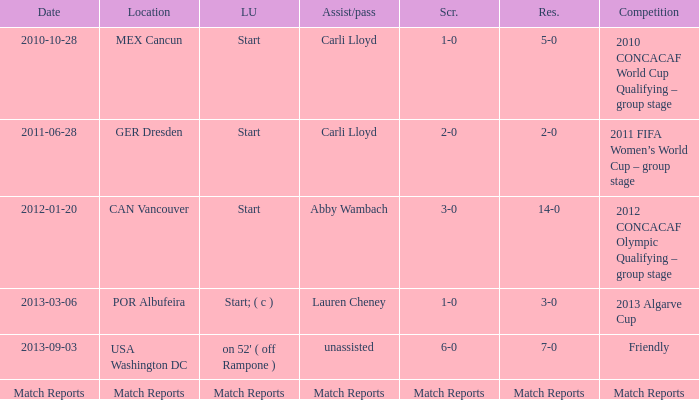Which score has a competition of match reports? Match Reports. 